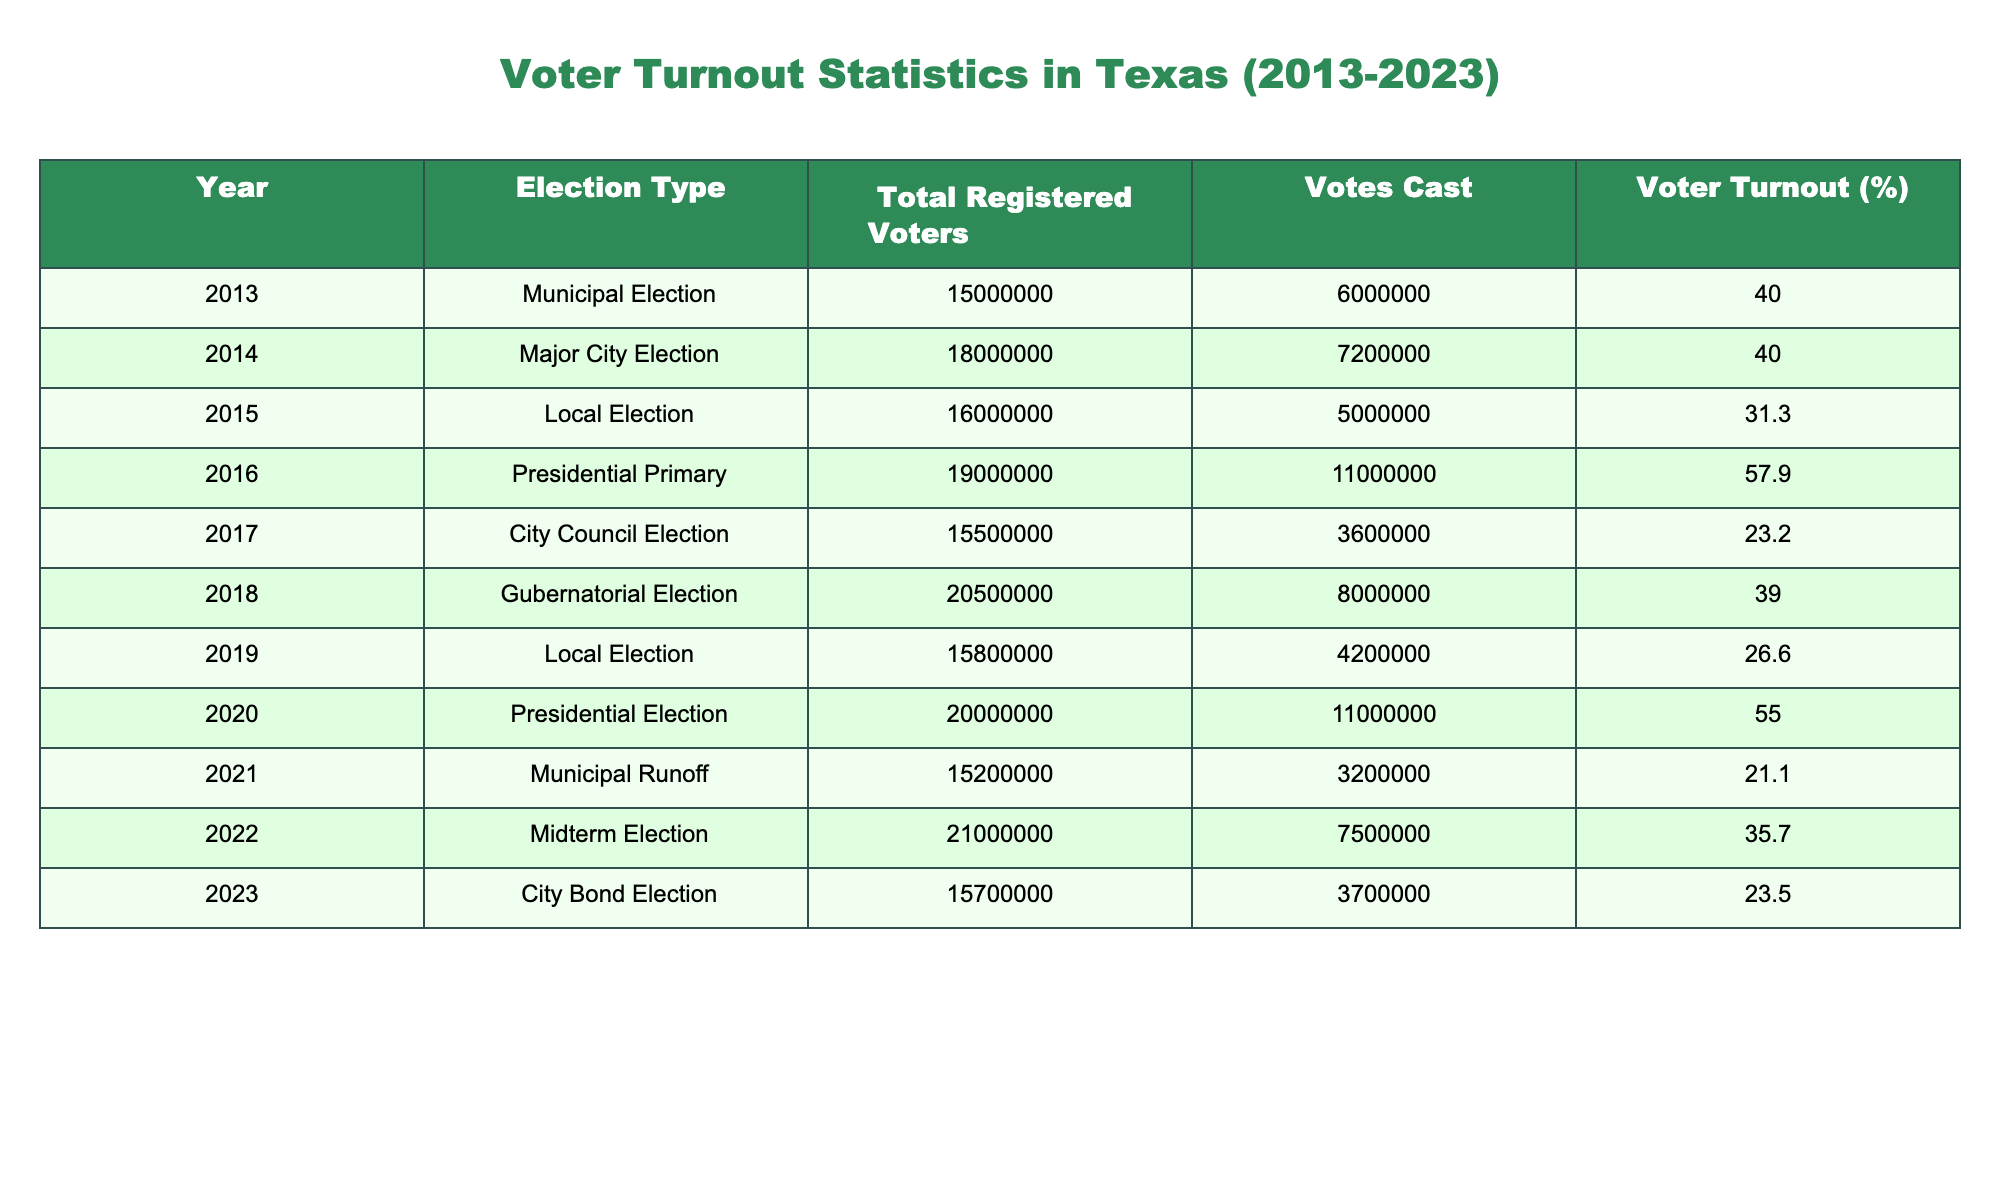What was the voter turnout for the 2017 City Council Election? The table shows the voter turnout percentage for each election year. In the row for the 2017 City Council Election, the voter turnout is noted as 23.2%.
Answer: 23.2% Which election in 2020 had the highest number of votes cast? In the 2020 Presidential Election, the votes cast totaled 11,000,000, which is the highest number for that year. Other entries have fewer votes cast.
Answer: 11,000,000 What is the average voter turnout percentage for local elections (2013, 2015, 2017, 2019, 2023)? First, we identify the voter turnout percentages for local elections: 40.0%, 31.3%, 23.2%, 26.6%, and 23.5%. Adding these gives 40.0 + 31.3 + 23.2 + 26.6 + 23.5 = 144.6. Then divide by 5 (the number of local elections) = 144.6 / 5 = 28.92%.
Answer: 28.92% Did the voter turnout in 2022 increase from the previous local election in 2019? The table shows that the voter turnout for 2019 was 26.6% and for 2022, it was 35.7%. Since 35.7% is greater than 26.6%, the voter turnout did indeed increase.
Answer: Yes Which election had the lowest voter turnout and what was that percentage? By examining the table, the lowest turnout is seen in the 2021 Municipal Runoff, with a turnout of 21.1%.
Answer: 21.1% How much did the total votes cast change from the 2014 Major City Election to the 2018 Gubernatorial Election? For the 2014 Major City Election, votes cast were 7,200,000, and for the 2018 Gubernatorial Election, votes cast were 8,000,000. The difference is 8,000,000 - 7,200,000 = 800,000 more votes cast in 2018.
Answer: 800,000 What was the voter turnout trend from 2013 to 2023? We look at the voter turnout percentages: 40.0% (2013), 40.0% (2014), 31.3% (2015), 57.9% (2016), 23.2% (2017), 39.0% (2018), 26.6% (2019), 55.0% (2020), 21.1% (2021), 35.7% (2022), and 23.5% (2023). The trend shows fluctuations with a high in 2016 of 57.9%, but otherwise no consistent increase or decrease. Overall, it varies greatly without a clear upward or downward trend.
Answer: Fluctuating without a clear trend 